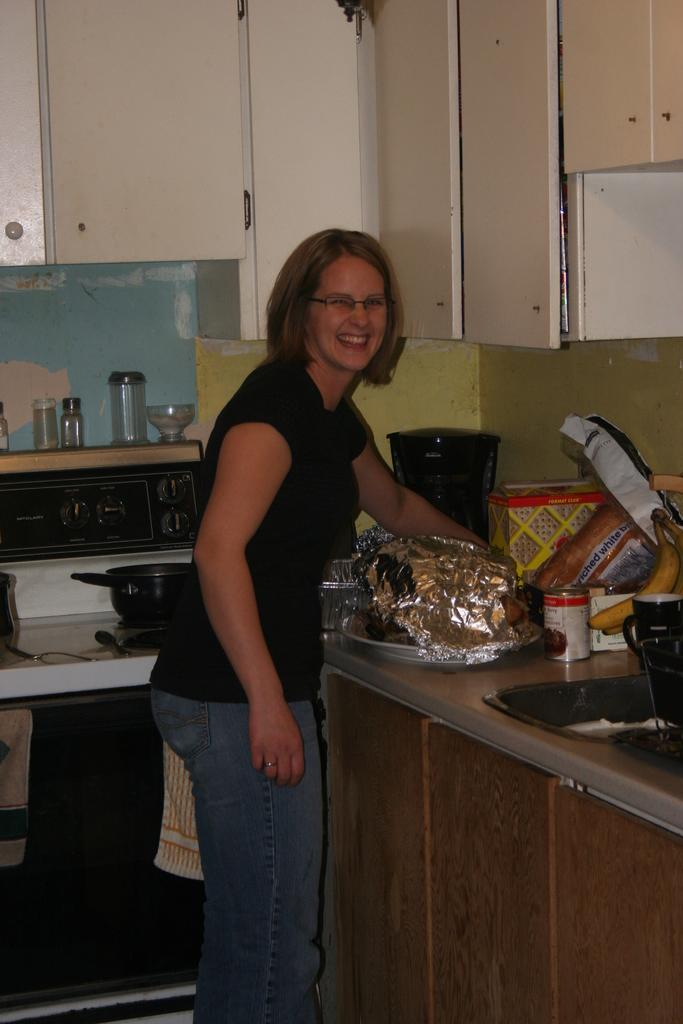<image>
Offer a succinct explanation of the picture presented. A woman leans over a counter where some enriched white bread is. 